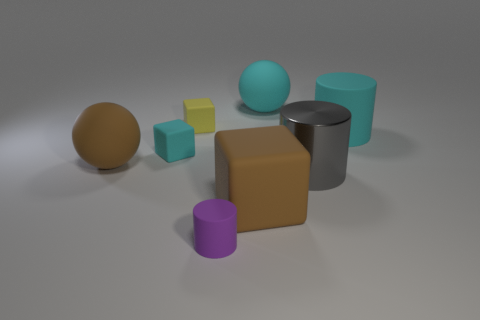Subtract all cyan cylinders. How many cylinders are left? 2 Subtract all cylinders. How many objects are left? 5 Subtract 2 cylinders. How many cylinders are left? 1 Subtract all brown balls. Subtract all blue cylinders. How many balls are left? 1 Subtract all blue spheres. How many yellow blocks are left? 1 Subtract all yellow objects. Subtract all tiny purple matte cylinders. How many objects are left? 6 Add 4 big gray things. How many big gray things are left? 5 Add 7 small yellow blocks. How many small yellow blocks exist? 8 Add 2 yellow matte cubes. How many objects exist? 10 Subtract all cyan cylinders. How many cylinders are left? 2 